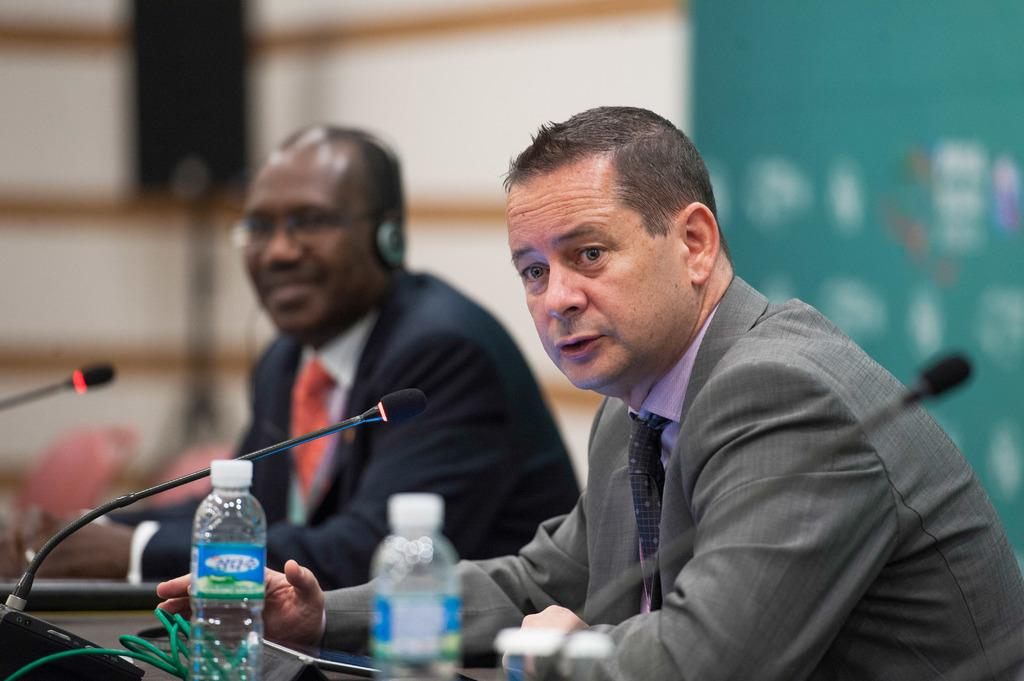How many people are in the image? There are 2 people in the image. What are the people doing in the image? The people are seated. What are the people wearing in the image? The people are wearing suits. What is in front of the people? There is a table in front of the people. What objects can be seen on the table? There are bottles and microphones on the table. Can you see a tiger walking in the background of the image? No, there is no tiger or any background visible in the image; it only shows two people seated at a table with bottles and microphones. 